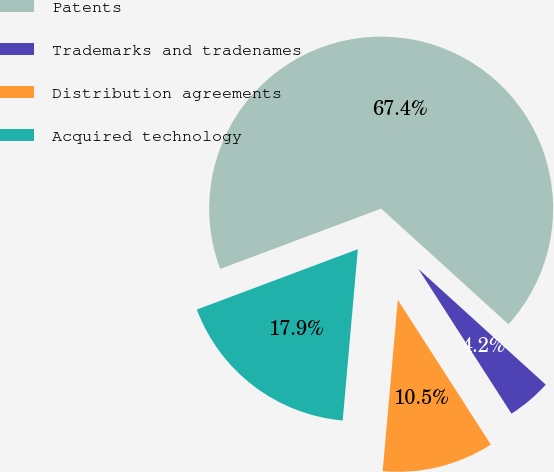Convert chart to OTSL. <chart><loc_0><loc_0><loc_500><loc_500><pie_chart><fcel>Patents<fcel>Trademarks and tradenames<fcel>Distribution agreements<fcel>Acquired technology<nl><fcel>67.45%<fcel>4.17%<fcel>10.5%<fcel>17.89%<nl></chart> 